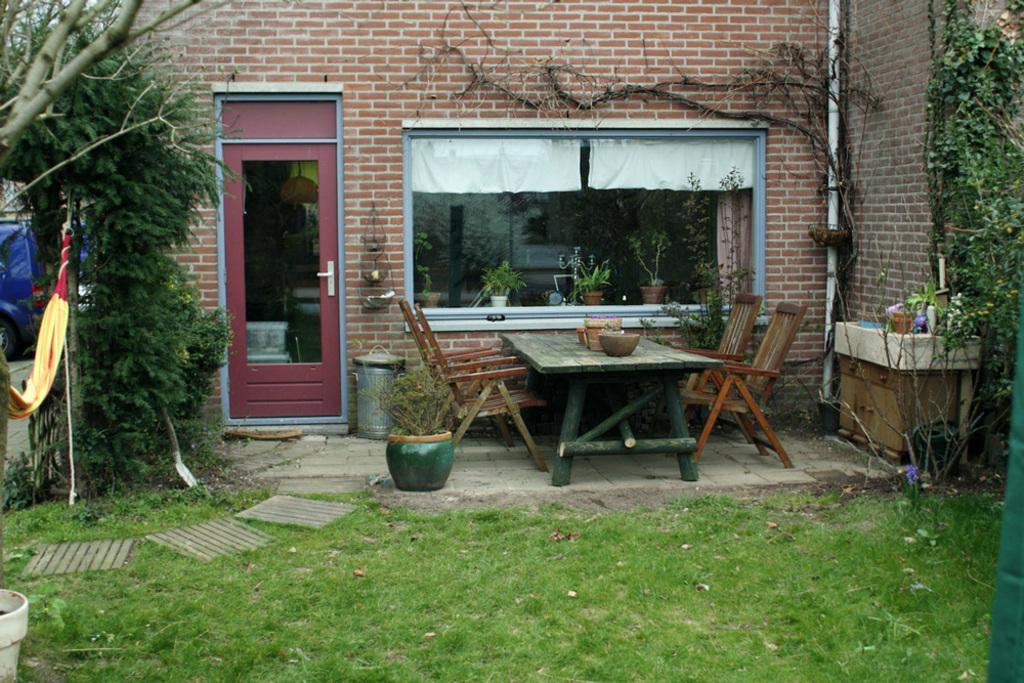Can you describe this image briefly? In this picture there is a wooden table and four wooden chairs, there is a glass window at the center of the image and there are some flower pots around the image area, there is a red color door at the left side of the image and there are some trees around the area and there is a grass floor and there is a plastic pole at the right side of the image 